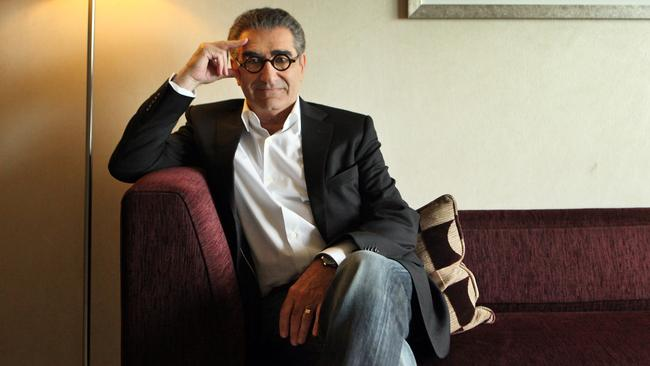Could you describe the artistic element visible in the background? The background features a framed painting, simple in its composition but elegant, likely chosen to complement the calming and stylish decor of the room, promoting a sense of tranquility and cultural appreciation. 